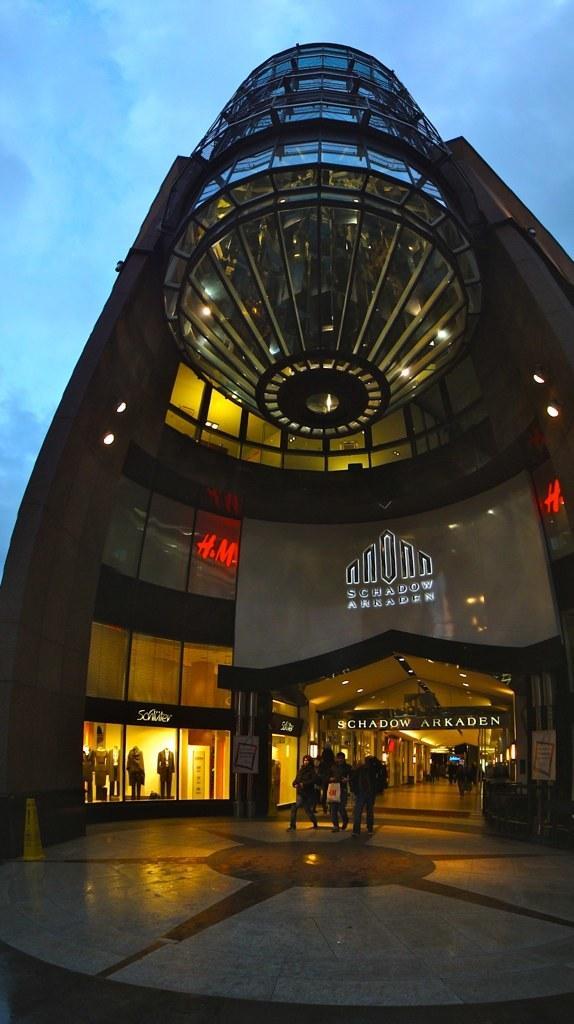Can you describe this image briefly? In this image there is a building in the middle, Under the building there are few people walking on the floor. At the bottom of the building there are stores. In the middle there is some text. At the top there are lights. It looks like a tall building. 